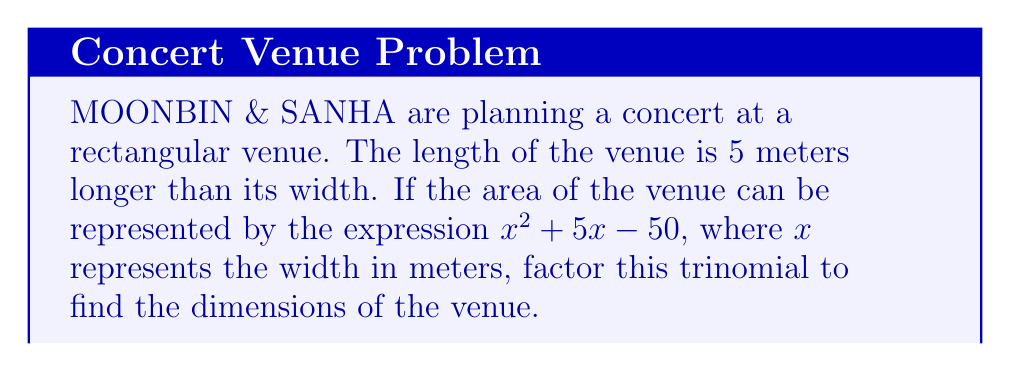Can you solve this math problem? Let's approach this step-by-step:

1) The trinomial to factor is $x^2 + 5x - 50$

2) We need to find two numbers that multiply to give $-50$ (the product of $a$ and $c$ in $ax^2 + bx + c$) and add up to $5$ (the coefficient of $x$).

3) The factors of $-50$ are: $±1, ±2, ±5, ±10, ±25, ±50$

4) By inspection, we can see that $10$ and $-5$ multiply to give $-50$ and add up to $5$

5) So, we can rewrite the middle term as: $x^2 + 10x - 5x - 50$

6) Now we can factor by grouping:
   $$(x^2 + 10x) + (-5x - 50)$$
   $$x(x + 10) - 5(x + 10)$$
   $$(x - 5)(x + 10)$$

7) Therefore, the factored form is $(x - 5)(x + 10)$

8) This means the width of the venue is $x$ meters and the length is $(x + 5)$ meters.

9) The roots of this equation are $x = 5$ or $x = -10$. Since width cannot be negative, $x = 5$.

10) So the width is 5 meters and the length is 10 meters.
Answer: $(x - 5)(x + 10)$ 